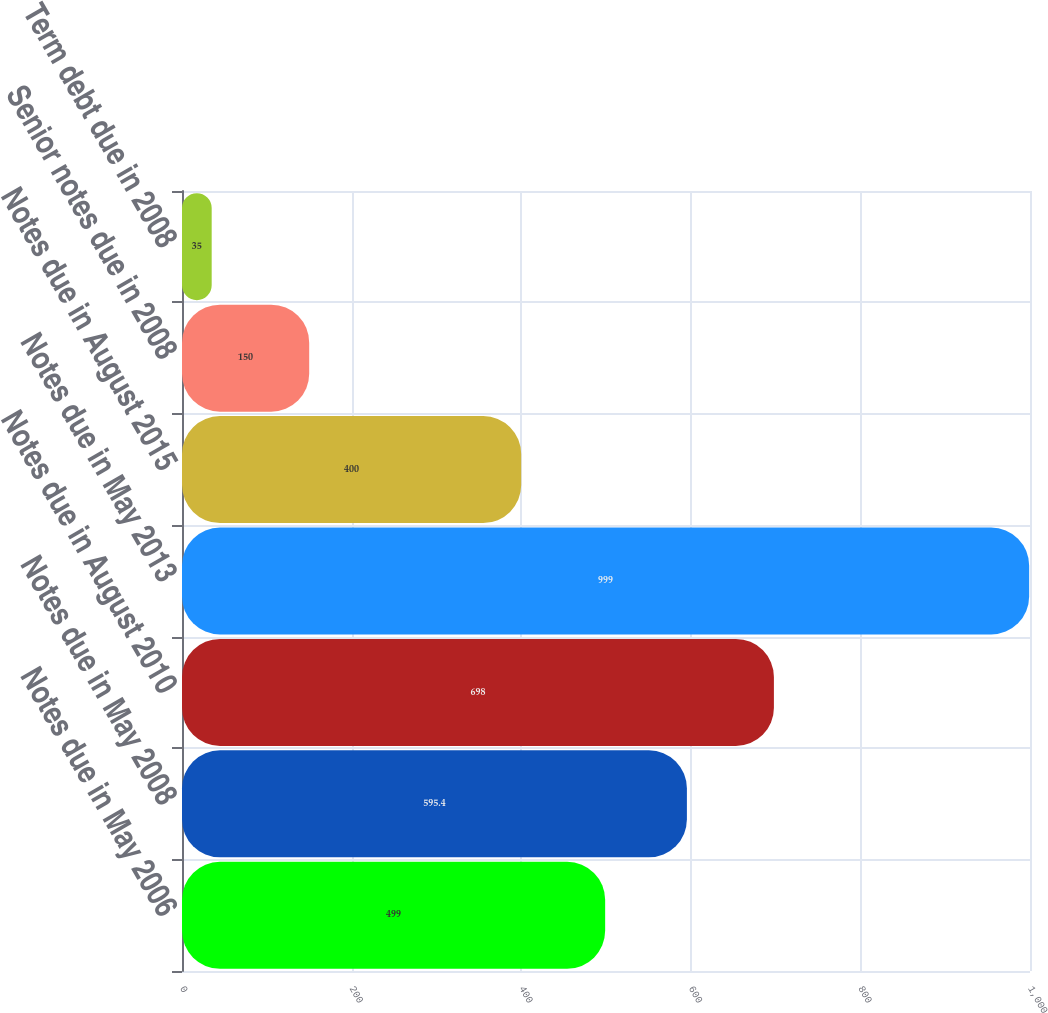Convert chart. <chart><loc_0><loc_0><loc_500><loc_500><bar_chart><fcel>Notes due in May 2006<fcel>Notes due in May 2008<fcel>Notes due in August 2010<fcel>Notes due in May 2013<fcel>Notes due in August 2015<fcel>Senior notes due in 2008<fcel>Term debt due in 2008<nl><fcel>499<fcel>595.4<fcel>698<fcel>999<fcel>400<fcel>150<fcel>35<nl></chart> 